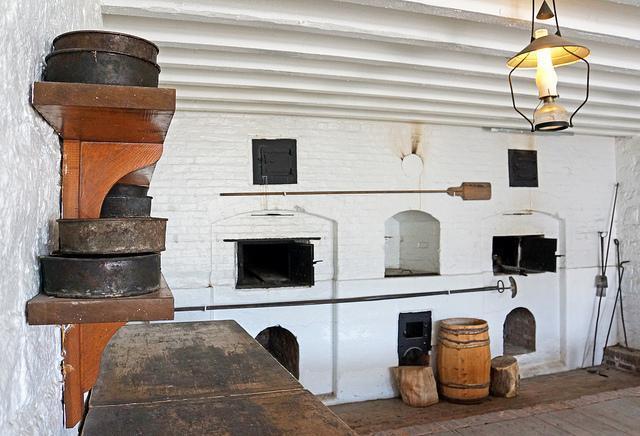How many ovens are there?
Give a very brief answer. 2. 